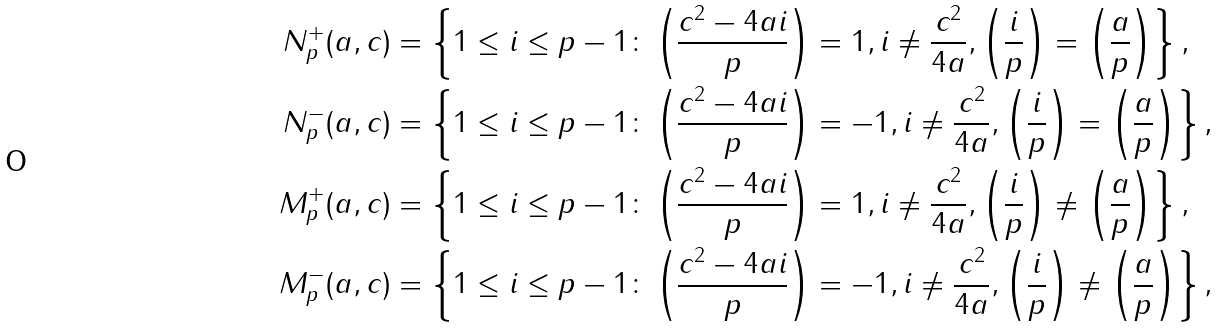Convert formula to latex. <formula><loc_0><loc_0><loc_500><loc_500>N _ { p } ^ { + } ( a , c ) & = \left \{ 1 \leq i \leq p - 1 \colon \left ( \frac { c ^ { 2 } - 4 a i } { p } \right ) = 1 , i \ne \frac { c ^ { 2 } } { 4 a } , \left ( \frac { i } { p } \right ) = \left ( \frac { a } { p } \right ) \right \} , \\ N _ { p } ^ { - } ( a , c ) & = \left \{ 1 \leq i \leq p - 1 \colon \left ( \frac { c ^ { 2 } - 4 a i } { p } \right ) = - 1 , i \ne \frac { c ^ { 2 } } { 4 a } , \left ( \frac { i } { p } \right ) = \left ( \frac { a } { p } \right ) \right \} , \\ M _ { p } ^ { + } ( a , c ) & = \left \{ 1 \leq i \leq p - 1 \colon \left ( \frac { c ^ { 2 } - 4 a i } { p } \right ) = 1 , i \ne \frac { c ^ { 2 } } { 4 a } , \left ( \frac { i } { p } \right ) \ne \left ( \frac { a } { p } \right ) \right \} , \\ M _ { p } ^ { - } ( a , c ) & = \left \{ 1 \leq i \leq p - 1 \colon \left ( \frac { c ^ { 2 } - 4 a i } { p } \right ) = - 1 , i \ne \frac { c ^ { 2 } } { 4 a } , \left ( \frac { i } { p } \right ) \ne \left ( \frac { a } { p } \right ) \right \} ,</formula> 